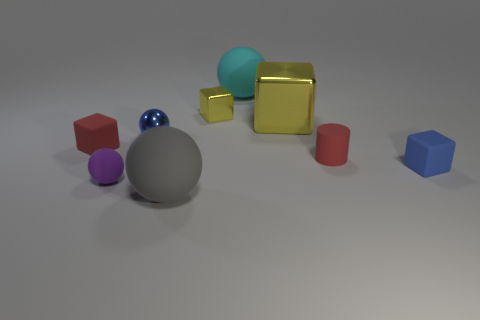What number of tiny yellow objects have the same material as the tiny red cylinder?
Your answer should be compact. 0. There is a metal ball; is it the same color as the tiny rubber cube right of the big gray sphere?
Give a very brief answer. Yes. What number of small rubber cubes are there?
Provide a short and direct response. 2. Is there a small block of the same color as the tiny rubber cylinder?
Give a very brief answer. Yes. What is the color of the big ball that is behind the large sphere in front of the matte cube on the left side of the cyan ball?
Keep it short and to the point. Cyan. Do the small red cube and the blue object that is on the left side of the gray sphere have the same material?
Keep it short and to the point. No. What is the tiny red cylinder made of?
Make the answer very short. Rubber. There is a tiny thing that is the same color as the rubber cylinder; what is it made of?
Ensure brevity in your answer.  Rubber. How many other objects are the same material as the small yellow cube?
Offer a very short reply. 2. What is the shape of the small matte thing that is to the left of the gray sphere and behind the tiny purple rubber thing?
Provide a succinct answer. Cube. 